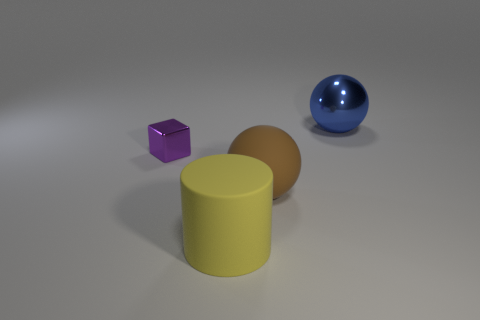Add 1 tiny red rubber objects. How many objects exist? 5 Subtract all cylinders. How many objects are left? 3 Subtract all small shiny objects. Subtract all big balls. How many objects are left? 1 Add 2 big metal balls. How many big metal balls are left? 3 Add 1 gray rubber cylinders. How many gray rubber cylinders exist? 1 Subtract 0 gray blocks. How many objects are left? 4 